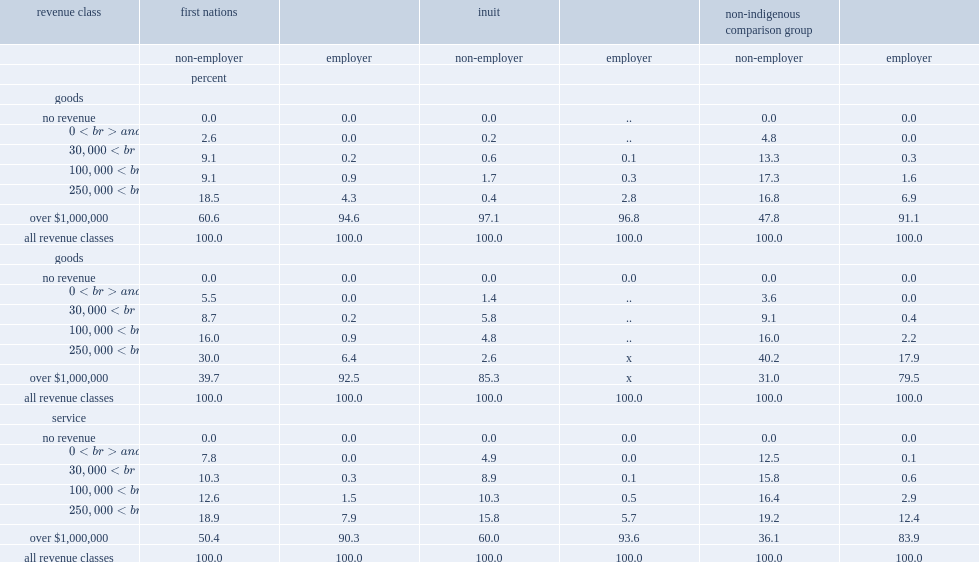Non-employer businesses in the goods (non-resource) and goods (resource) industries which operate in inuit csds break from this trend, which type of employer had higher percent as in both cases the share of revenues from the over-$1,000,000 class, non-employer or employer businesses? Non-employer. Non-employer businesses in the goods (non-resource) and goods (resource) industries which operate in inuit csds break from this trend, which type of employer had higher percent as in both cases the share of revenues from the over-$1,000,000 class, non-employer or employer businesses? Non-employer. 